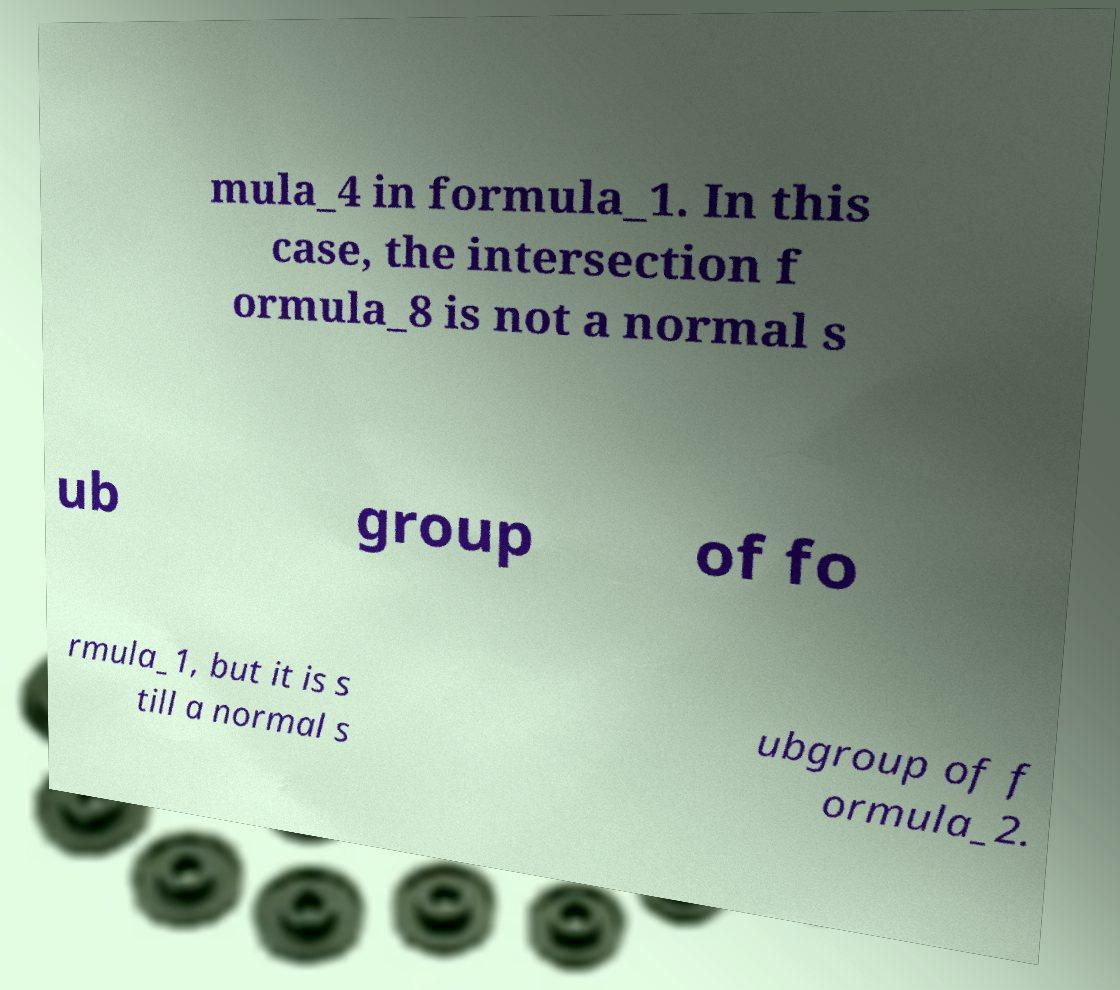Please read and relay the text visible in this image. What does it say? mula_4 in formula_1. In this case, the intersection f ormula_8 is not a normal s ub group of fo rmula_1, but it is s till a normal s ubgroup of f ormula_2. 